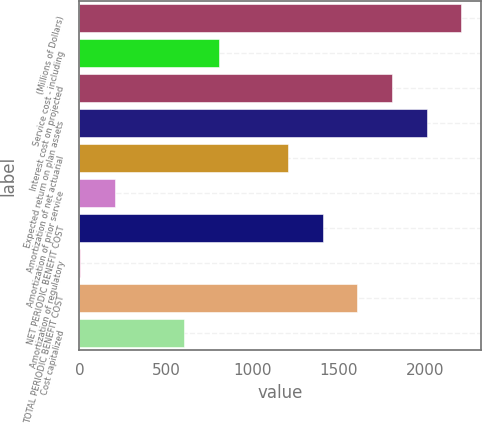Convert chart to OTSL. <chart><loc_0><loc_0><loc_500><loc_500><bar_chart><fcel>(Millions of Dollars)<fcel>Service cost - including<fcel>Interest cost on projected<fcel>Expected return on plan assets<fcel>Amortization of net actuarial<fcel>Amortization of prior service<fcel>NET PERIODIC BENEFIT COST<fcel>Amortization of regulatory<fcel>TOTAL PERIODIC BENEFIT COST<fcel>Cost capitalized<nl><fcel>2210.8<fcel>805.2<fcel>1809.2<fcel>2010<fcel>1206.8<fcel>202.8<fcel>1407.6<fcel>2<fcel>1608.4<fcel>604.4<nl></chart> 